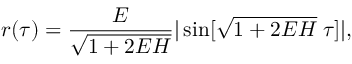Convert formula to latex. <formula><loc_0><loc_0><loc_500><loc_500>r ( \tau ) = \frac { E } { \sqrt { 1 + 2 E H } } | \sin [ \sqrt { 1 + 2 E H } \, \tau ] | ,</formula> 